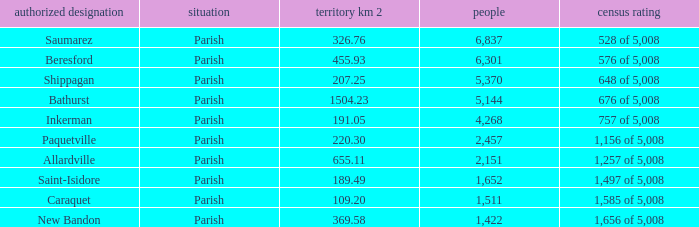What is the Area of the Saint-Isidore Parish with a Population smaller than 4,268? 189.49. 